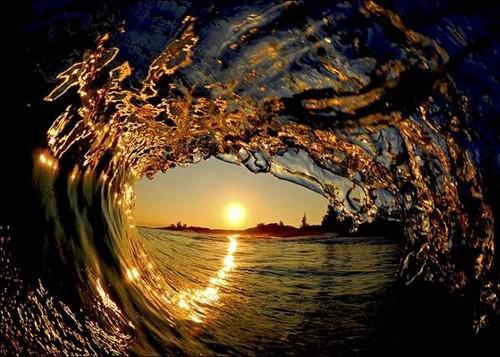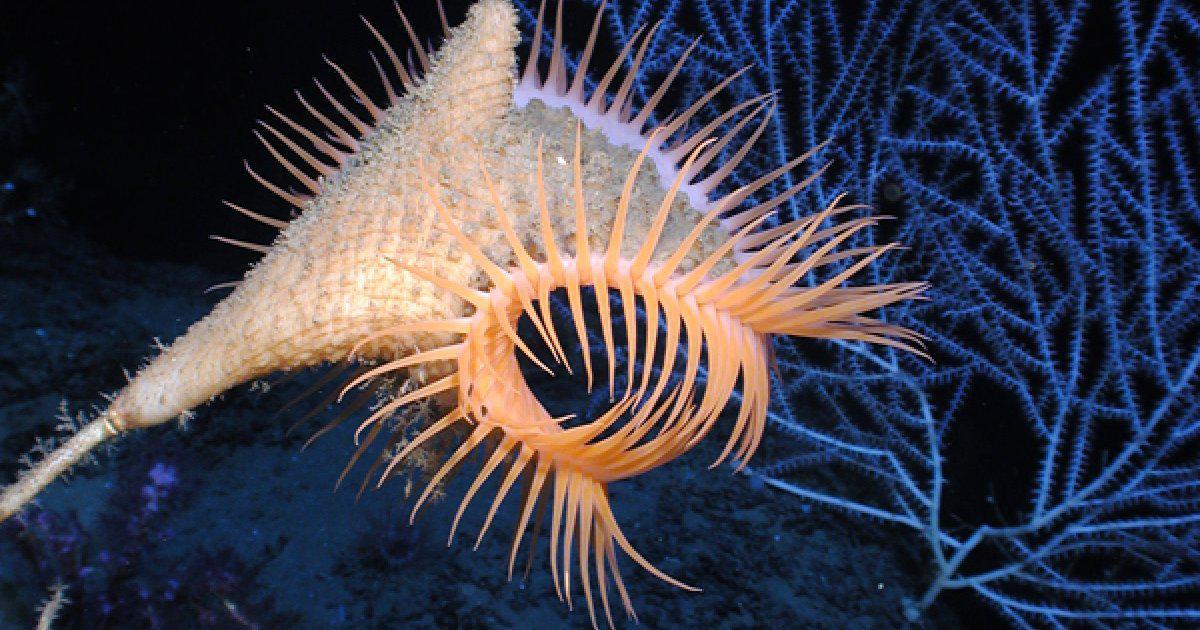The first image is the image on the left, the second image is the image on the right. Evaluate the accuracy of this statement regarding the images: "One sea anemone has a visible mouth.". Is it true? Answer yes or no. No. 